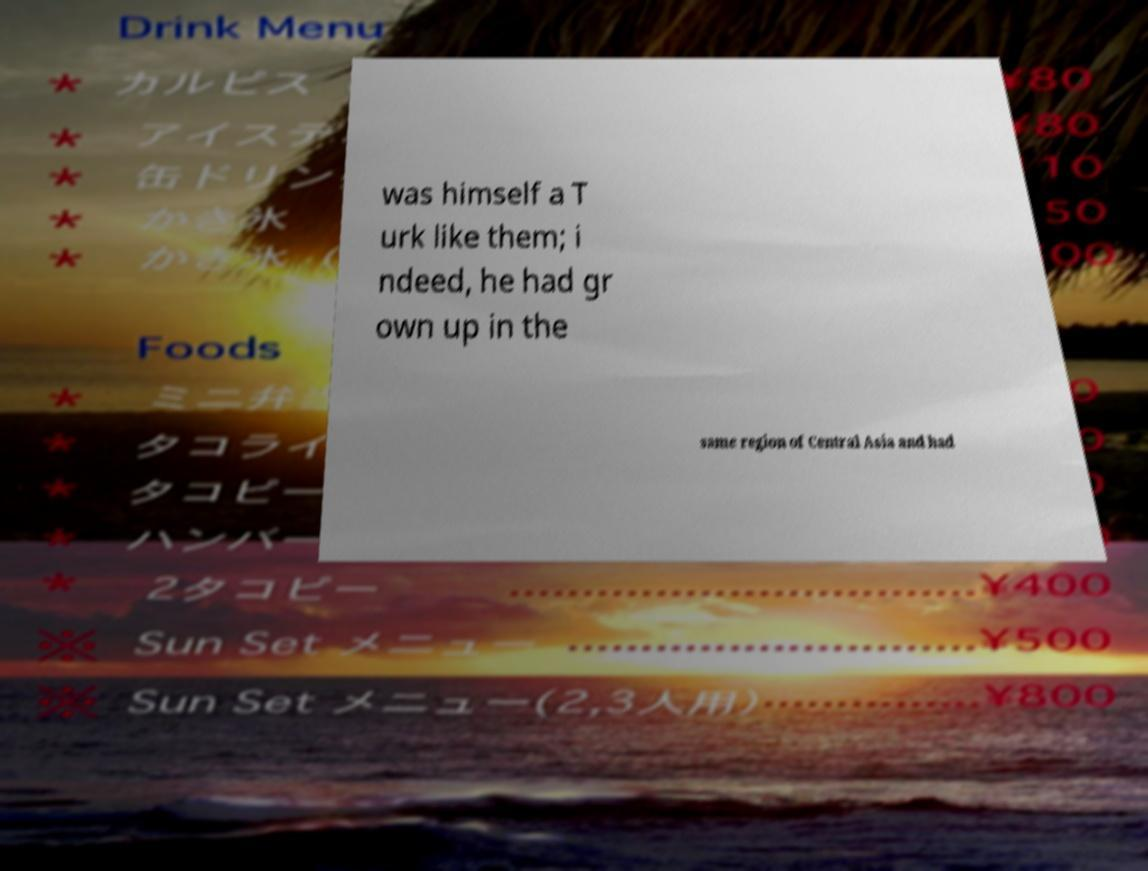Could you assist in decoding the text presented in this image and type it out clearly? was himself a T urk like them; i ndeed, he had gr own up in the same region of Central Asia and had 